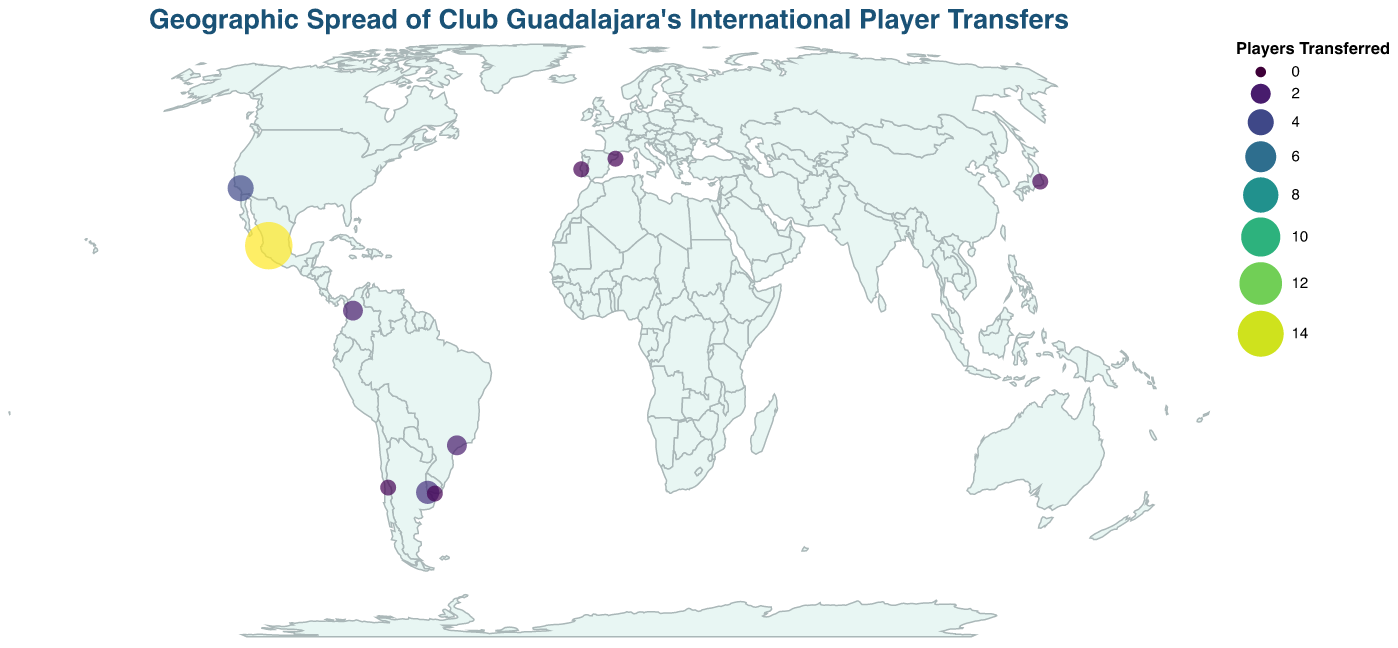Where is the highest number of player transfers concentrated? The highest number of player transfers is represented by the largest circle and is located in Guadalajara, Mexico.
Answer: Guadalajara, Mexico Which city in the United States has had player transfers with Club Guadalajara? The data shows a circle in Los Angeles, which indicates that it is the city in the United States where Club Guadalajara has had player transfers.
Answer: Los Angeles How many players were transferred from Buenos Aires? The circle over Buenos Aires represents 3 player transfers, as indicated by the size and the quantity data.
Answer: 3 Compare the number of players transferred from Los Angeles and São Paulo. Which city had a higher number? Los Angeles had 4 player transfers, while São Paulo had 2. Therefore, Los Angeles had a higher number of player transfers.
Answer: Los Angeles What is the approximate latitude and longitude of Santiago where Club Guadalajara had player transfers? The plot shows Santiago with a latitude of approximately -33.4489 and a longitude of approximately -70.6693.
Answer: (-33.4489, -70.6693) How many cities in South America have had player transfers with Club Guadalajara? The South American cities listed are Buenos Aires, Medellín, São Paulo, Santiago, and Montevideo, making a total of 5 cities.
Answer: 5 Which continent has the most cities involved in player transfers with Club Guadalajara? North America (Guadalajara, Mexico and Los Angeles, United States) and South America (Buenos Aires, Medellín, São Paulo, Santiago, Montevideo). Given that South America has more cities listed, it has the most cities involved.
Answer: South America Are there any countries in Asia from where players were transferred to Club Guadalajara? There is a circle representing player transfers in Tokyo, Japan, indicating that there have been player transfers from Asia.
Answer: Yes What is the color scheme used to indicate the number of player transfers on the map? The color scheme used is "viridis," which varies in color intensity based on the number of player transfers.
Answer: viridis Calculate the total number of player transfers represented in this plot. Summing the values for all cities: 15 (Guadalajara) + 4 (Los Angeles) + 3 (Buenos Aires) + 2 (Medellín) + 2 (São Paulo) + 1 (Barcelona) + 1 (Tokyo) + 1 (Lisbon) + 1 (Santiago) + 1 (Montevideo) = 31.
Answer: 31 